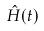Convert formula to latex. <formula><loc_0><loc_0><loc_500><loc_500>\hat { H } ( t )</formula> 